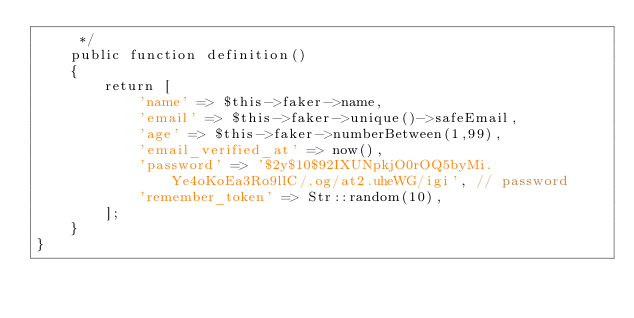Convert code to text. <code><loc_0><loc_0><loc_500><loc_500><_PHP_>     */
    public function definition()
    {
        return [
            'name' => $this->faker->name,
            'email' => $this->faker->unique()->safeEmail,
            'age' => $this->faker->numberBetween(1,99),
            'email_verified_at' => now(),
            'password' => '$2y$10$92IXUNpkjO0rOQ5byMi.Ye4oKoEa3Ro9llC/.og/at2.uheWG/igi', // password
            'remember_token' => Str::random(10),
        ];
    }
}
</code> 